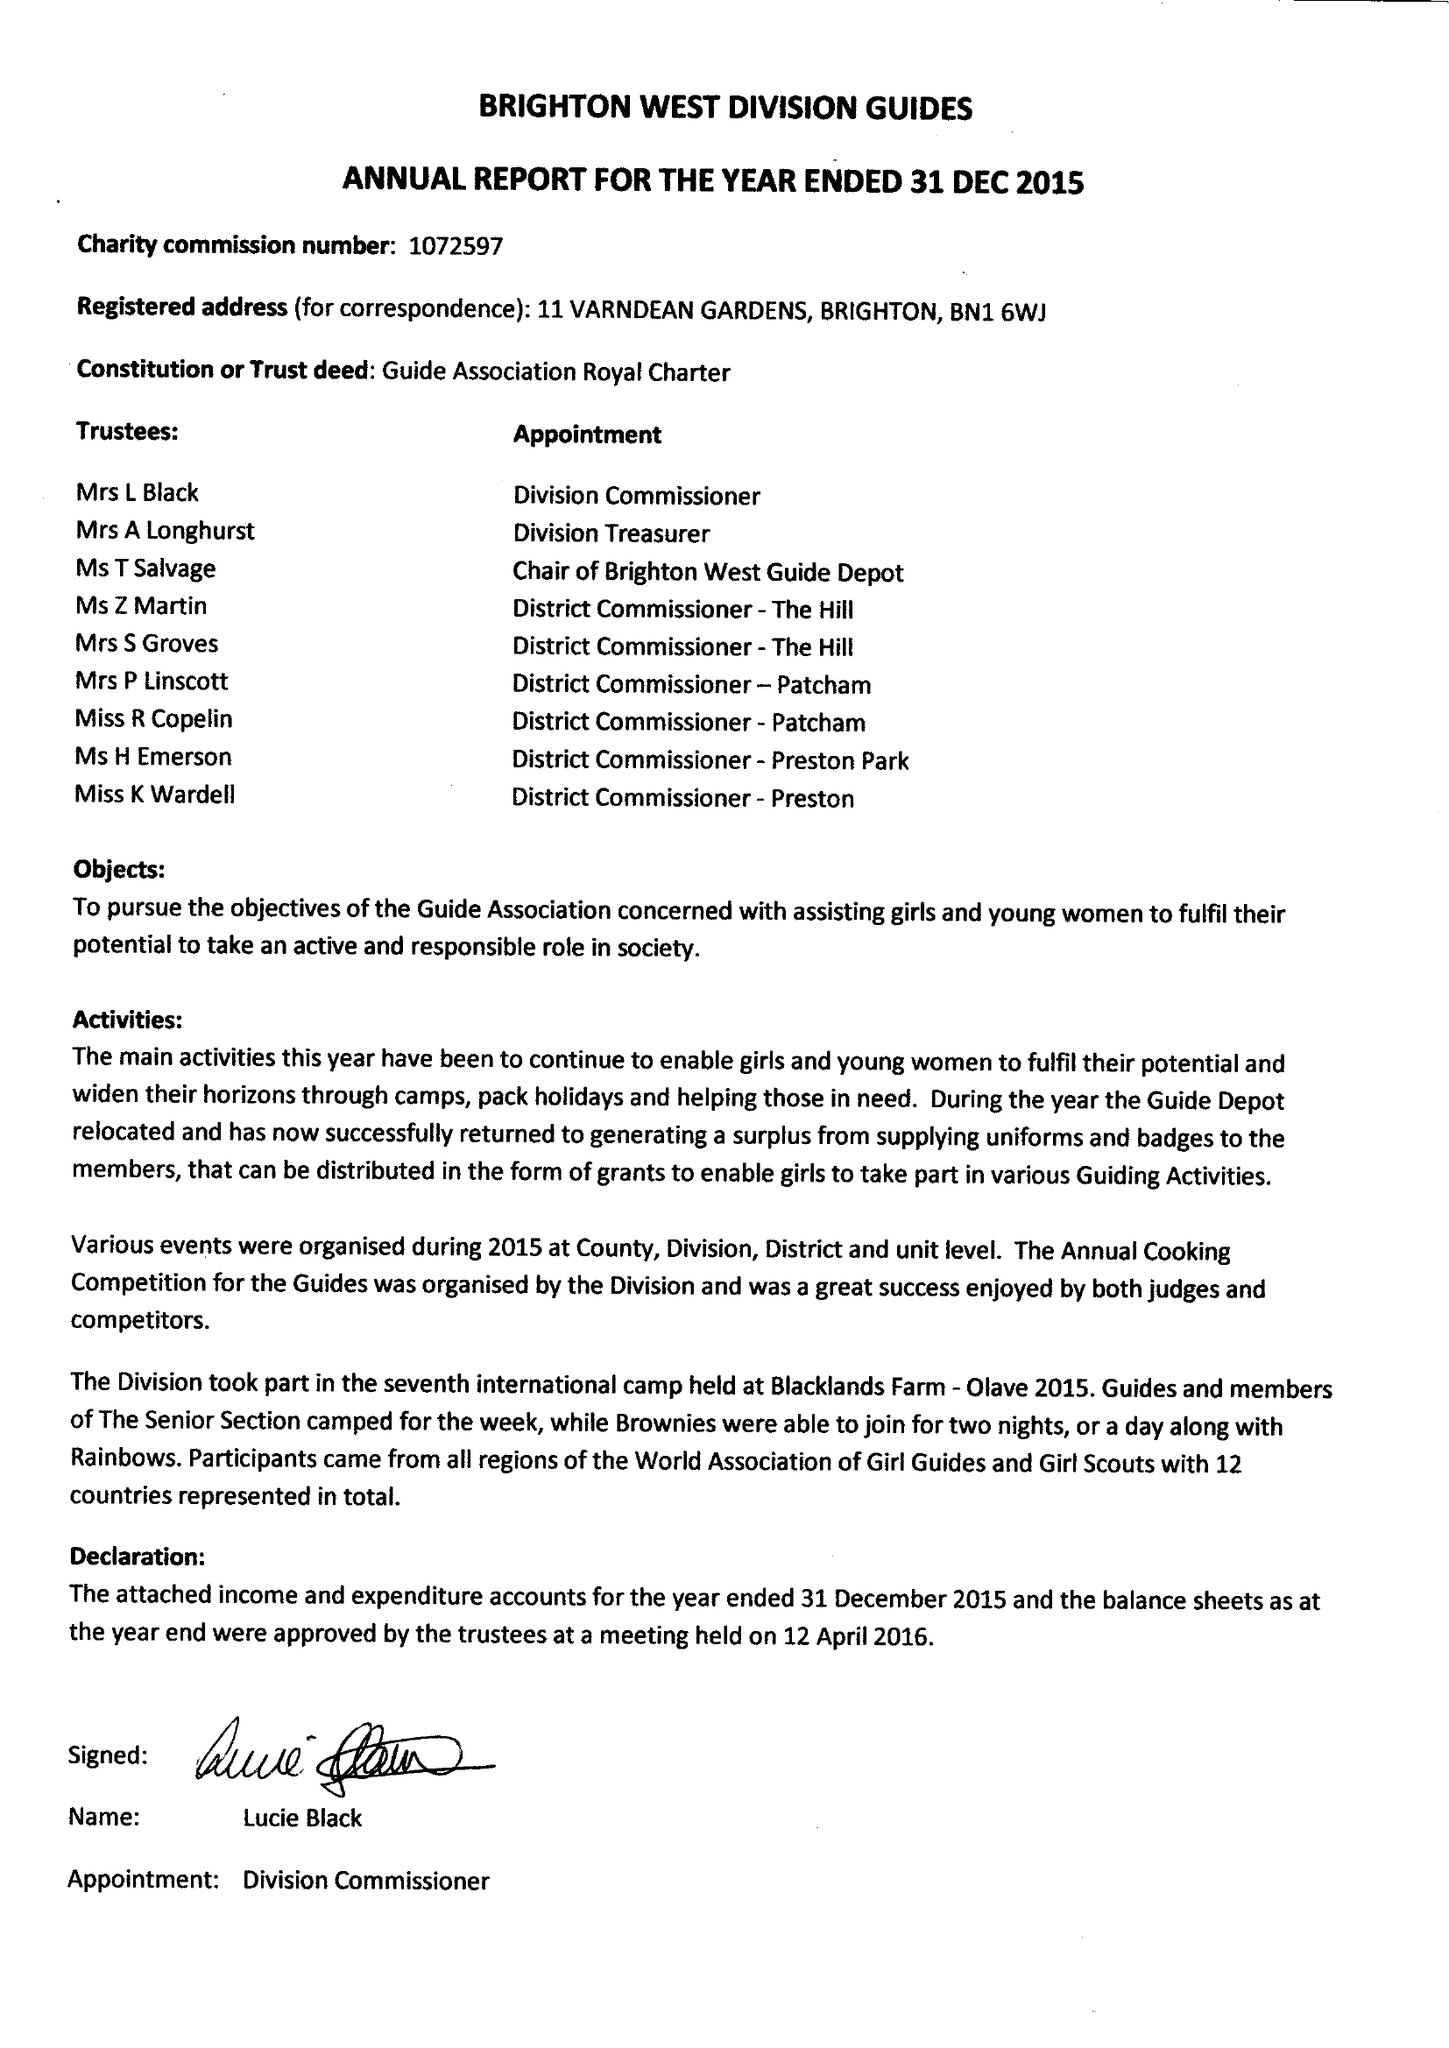What is the value for the spending_annually_in_british_pounds?
Answer the question using a single word or phrase. 25262.00 